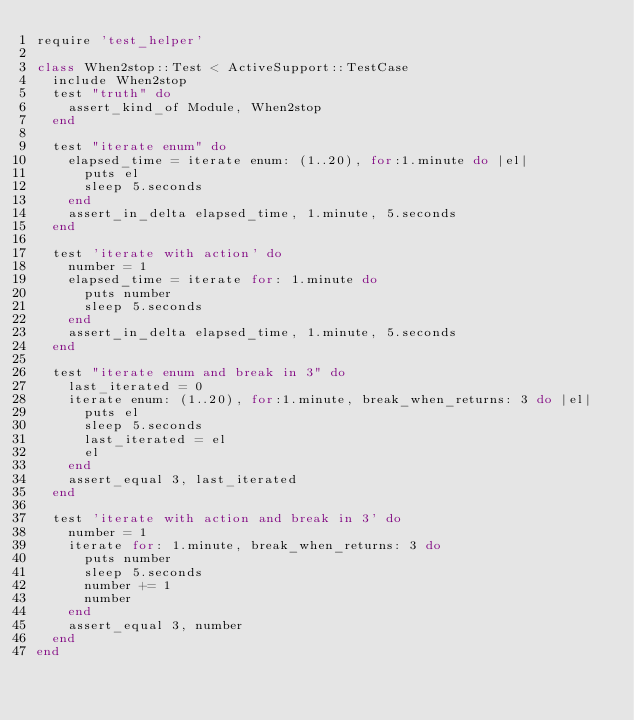Convert code to text. <code><loc_0><loc_0><loc_500><loc_500><_Ruby_>require 'test_helper'

class When2stop::Test < ActiveSupport::TestCase
  include When2stop
  test "truth" do
    assert_kind_of Module, When2stop
  end

  test "iterate enum" do
    elapsed_time = iterate enum: (1..20), for:1.minute do |el|
      puts el
      sleep 5.seconds
    end
    assert_in_delta elapsed_time, 1.minute, 5.seconds
  end

  test 'iterate with action' do
    number = 1
    elapsed_time = iterate for: 1.minute do
      puts number
      sleep 5.seconds
    end
    assert_in_delta elapsed_time, 1.minute, 5.seconds
  end

  test "iterate enum and break in 3" do
    last_iterated = 0
    iterate enum: (1..20), for:1.minute, break_when_returns: 3 do |el|
      puts el
      sleep 5.seconds
      last_iterated = el
      el
    end
    assert_equal 3, last_iterated
  end

  test 'iterate with action and break in 3' do
    number = 1
    iterate for: 1.minute, break_when_returns: 3 do
      puts number
      sleep 5.seconds
      number += 1
      number
    end
    assert_equal 3, number
  end
end
</code> 